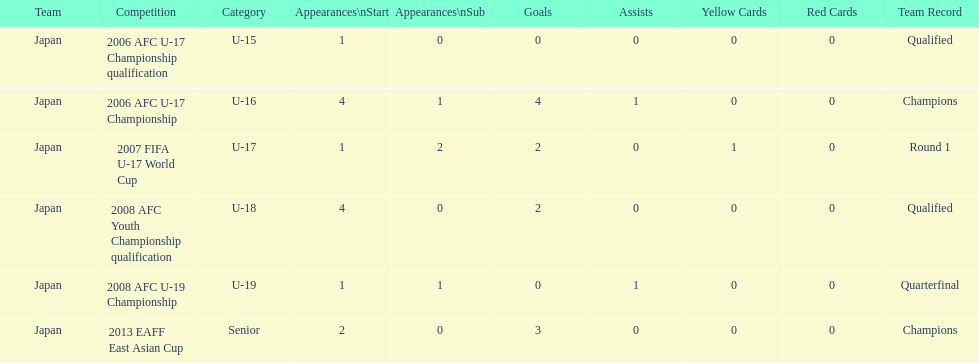In which major competitions did yoichiro kakitani have at least 3 starts? 2006 AFC U-17 Championship, 2008 AFC Youth Championship qualification. 